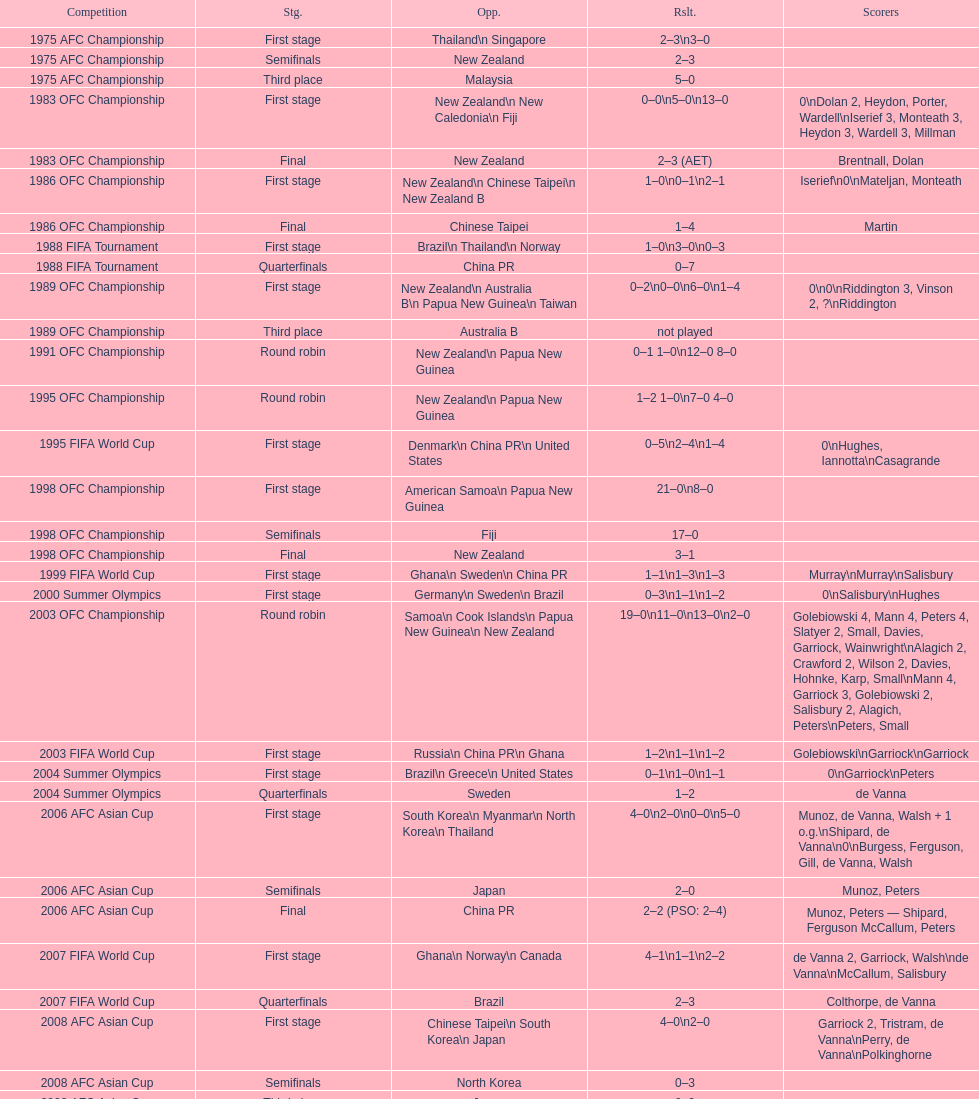Who scored better in the 1995 fifa world cup denmark or the united states? United States. 